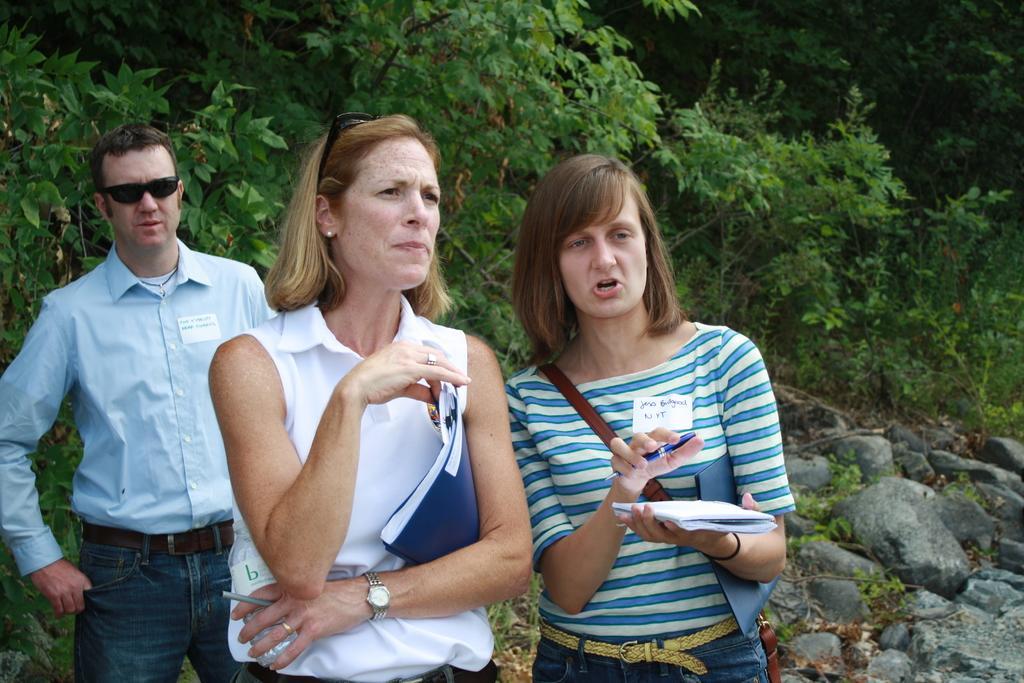Can you describe this image briefly? In the image we can see two women and women standing and wearing clothes. We can see the men wearing spectacles and the woman is wearing finger ring, wrist watch and ear studs, and they are holding objects in their hands. Here we can see stones and plants. 